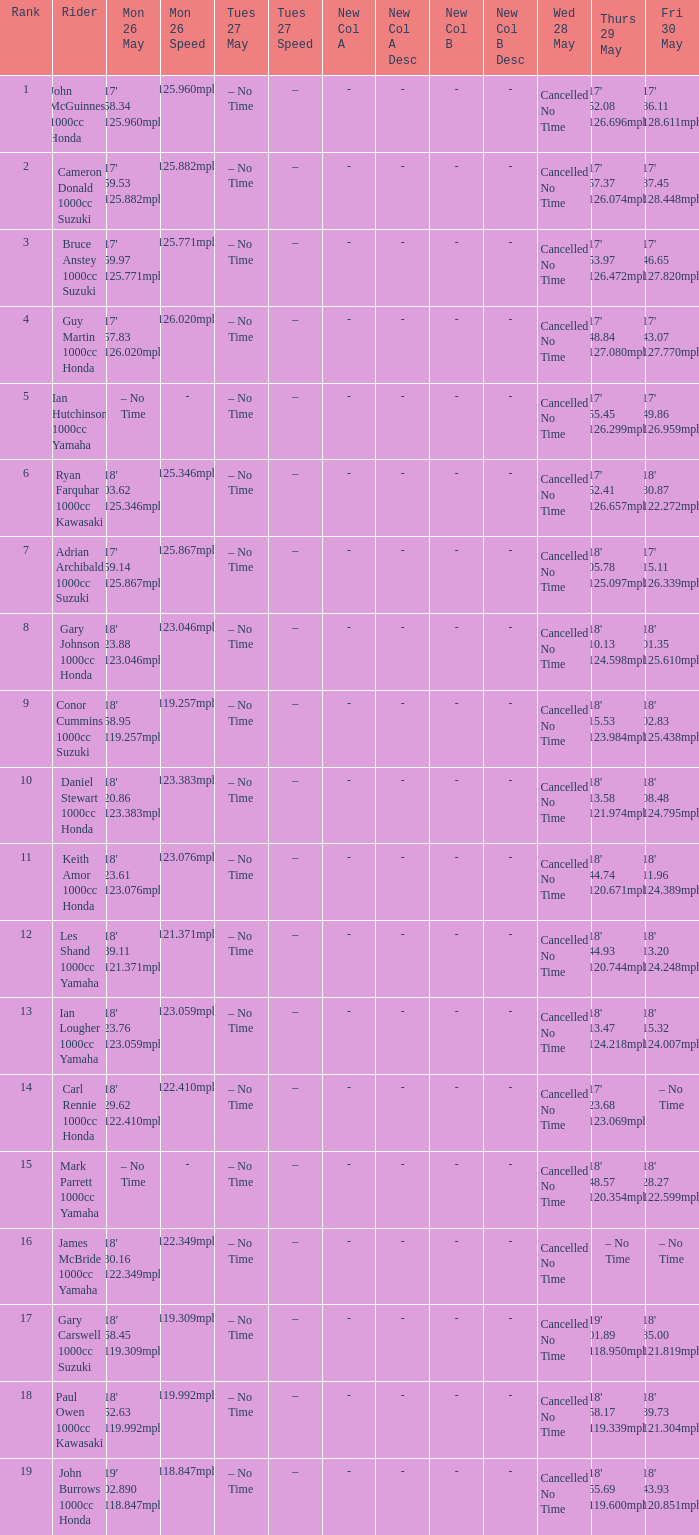What time is mon may 26 and fri may 30 is 18' 28.27 122.599mph? – No Time. 